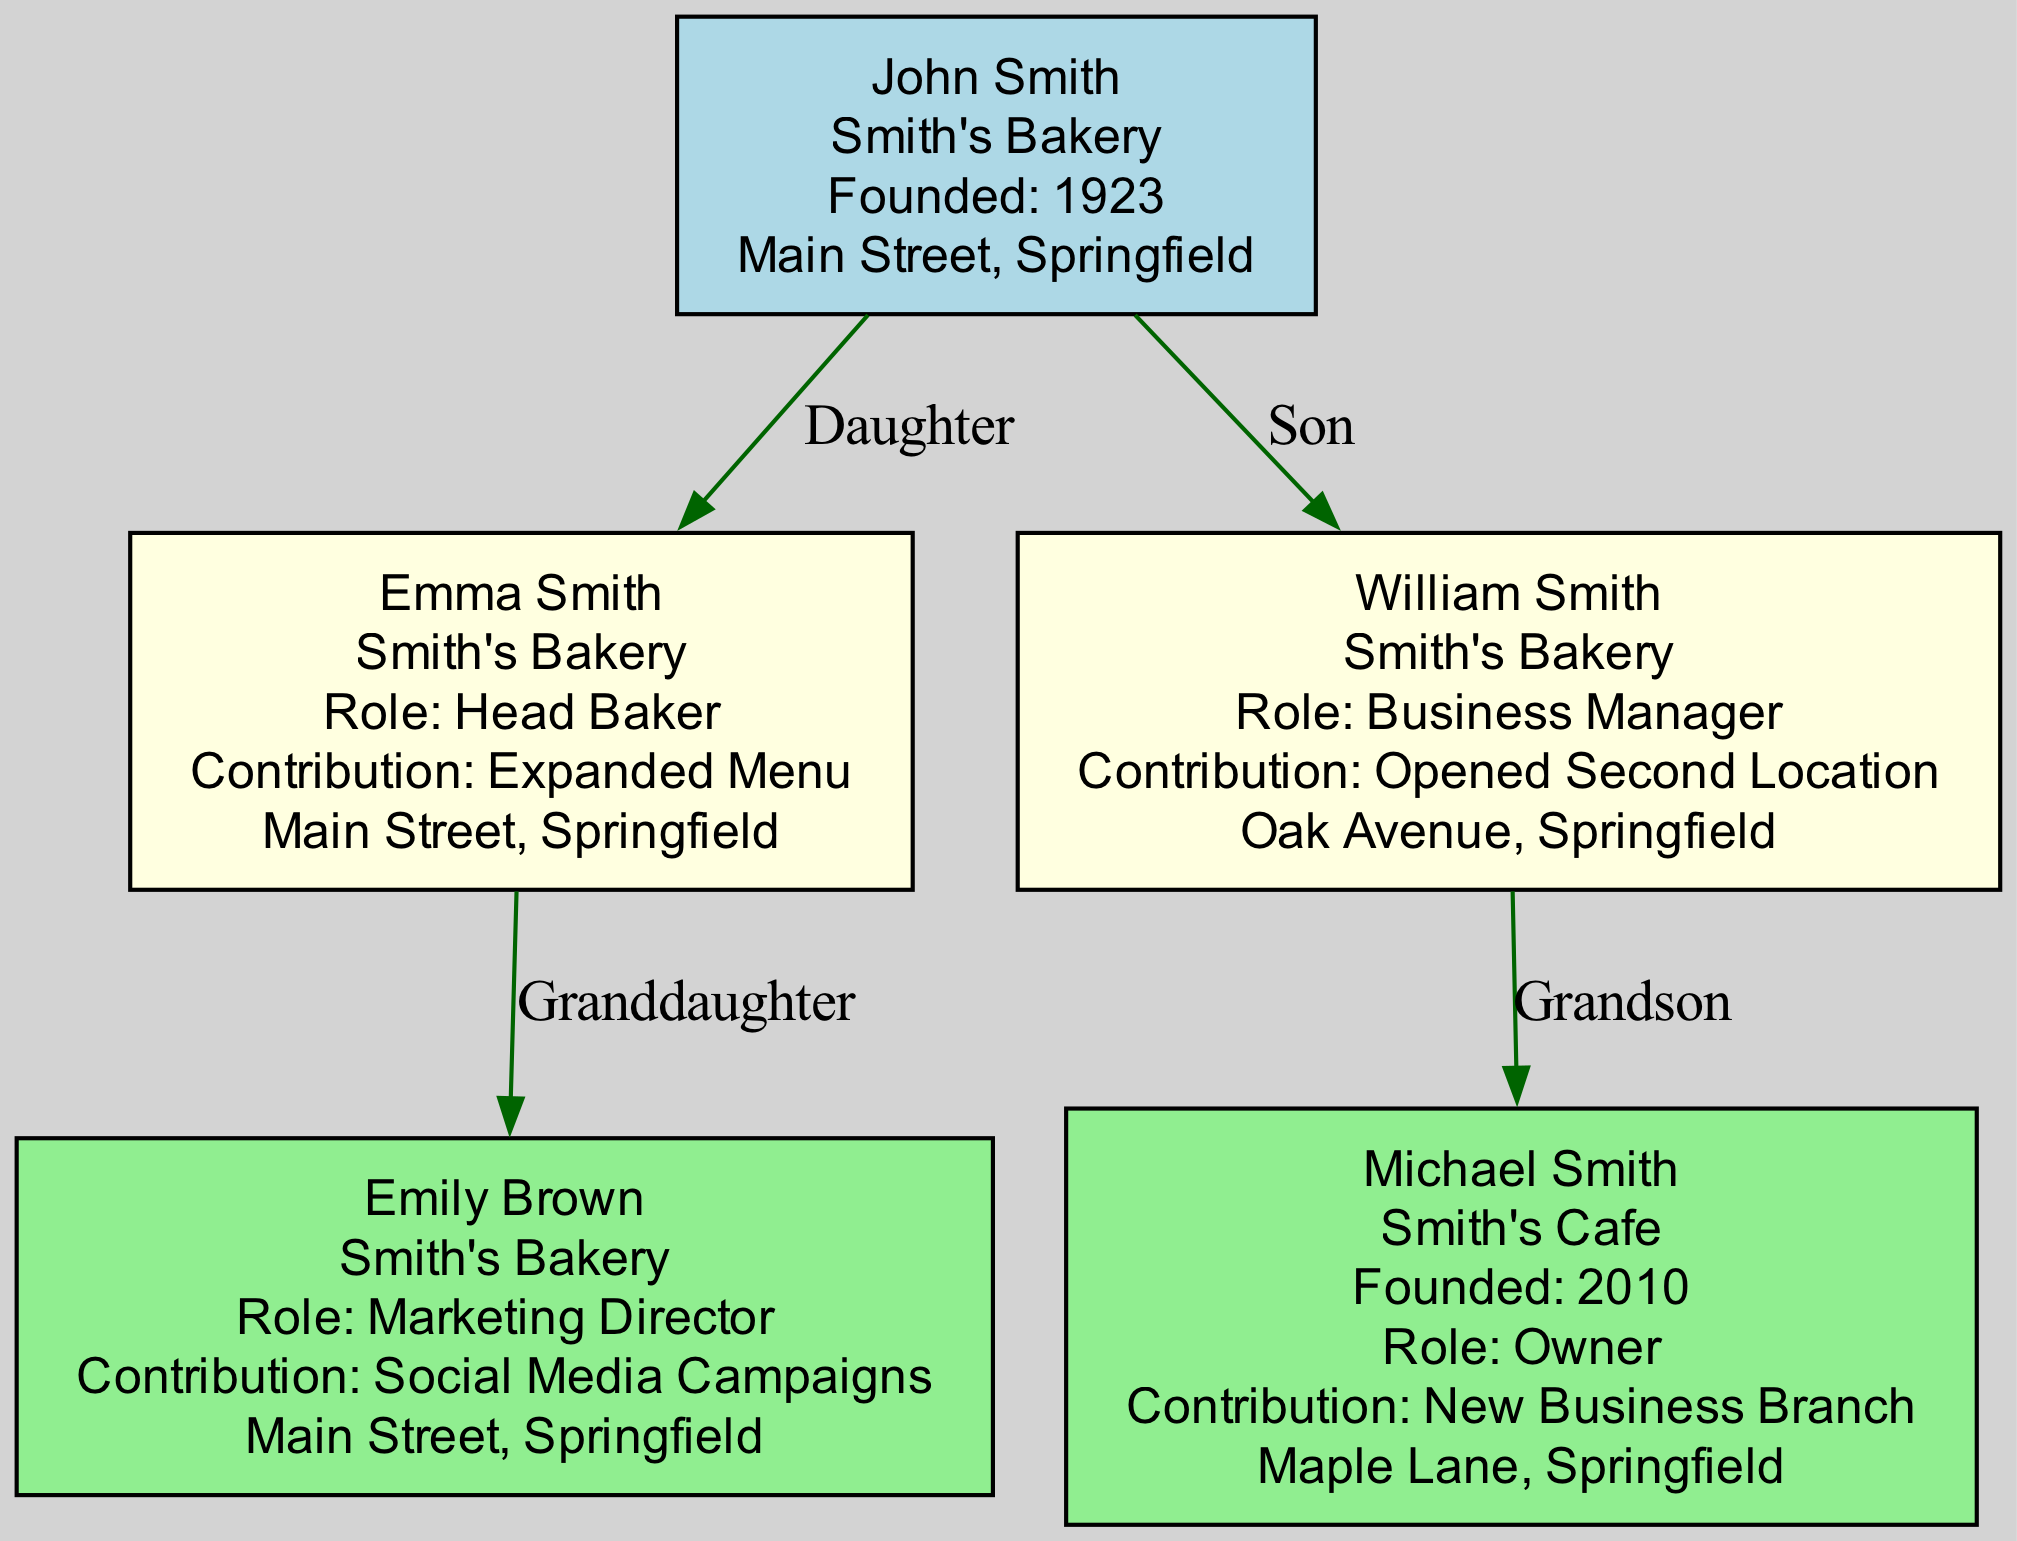What is the name of the founder? The diagram shows the node labeled 'founder' which includes the information about the founder. The name is clearly stated as "John Smith."
Answer: John Smith What year was Smith's Bakery founded? In the diagram, the founder's node contains the details about the business, including the founding year, which is stated as 1923.
Answer: 1923 How many second-generation members are there? By examining the second generation section of the diagram, it shows a total of two members: Emma Smith and William Smith.
Answer: 2 What is the role of Emily Brown? The diagram illustrates Emily Brown's details in the third-generation section, indicating her role as "Marketing Director."
Answer: Marketing Director Which business did Michael Smith establish? Looking at the third generation, the node for Michael Smith specifies that he owns "Smith's Cafe," which is a new business branch he established.
Answer: Smith's Cafe Who opened the second location of Smith's Bakery? The node for William Smith in the second generation indicates that he is the business manager and contributed by opening a second location of Smith's Bakery.
Answer: William Smith Where is Smith's Cafe located? The diagram provides the location for Michael Smith's business, clearly indicating it is located on "Maple Lane, Springfield."
Answer: Maple Lane, Springfield Which generation does Emma Smith belong to? By analyzing the relation of the nodes, Emma Smith is listed under the second-generation section as the daughter of John Smith, the founder.
Answer: Second generation What contribution did Emily Brown make? In her node, the diagram highlights that Emily Brown contributed by executing "Social Media Campaigns" for Smith's Bakery.
Answer: Social Media Campaigns What is the relationship between William Smith and John Smith? The diagram shows that William Smith is labeled as the son, establishing a direct relationship where he is a child of John Smith, the founder.
Answer: Son 